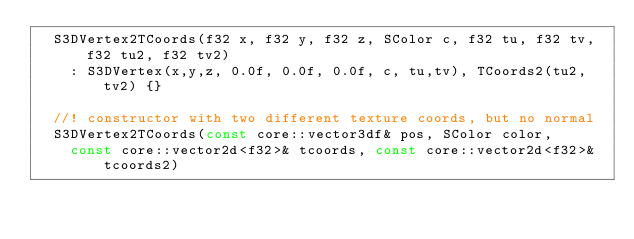Convert code to text. <code><loc_0><loc_0><loc_500><loc_500><_C_>	S3DVertex2TCoords(f32 x, f32 y, f32 z, SColor c, f32 tu, f32 tv, f32 tu2, f32 tv2)
		: S3DVertex(x,y,z, 0.0f, 0.0f, 0.0f, c, tu,tv), TCoords2(tu2,tv2) {}

	//! constructor with two different texture coords, but no normal
	S3DVertex2TCoords(const core::vector3df& pos, SColor color,
		const core::vector2d<f32>& tcoords, const core::vector2d<f32>& tcoords2)</code> 